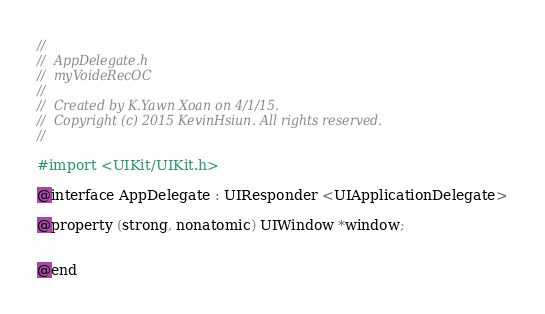Convert code to text. <code><loc_0><loc_0><loc_500><loc_500><_C_>//
//  AppDelegate.h
//  myVoideRecOC
//
//  Created by K.Yawn Xoan on 4/1/15.
//  Copyright (c) 2015 KevinHsiun. All rights reserved.
//

#import <UIKit/UIKit.h>

@interface AppDelegate : UIResponder <UIApplicationDelegate>

@property (strong, nonatomic) UIWindow *window;


@end

</code> 